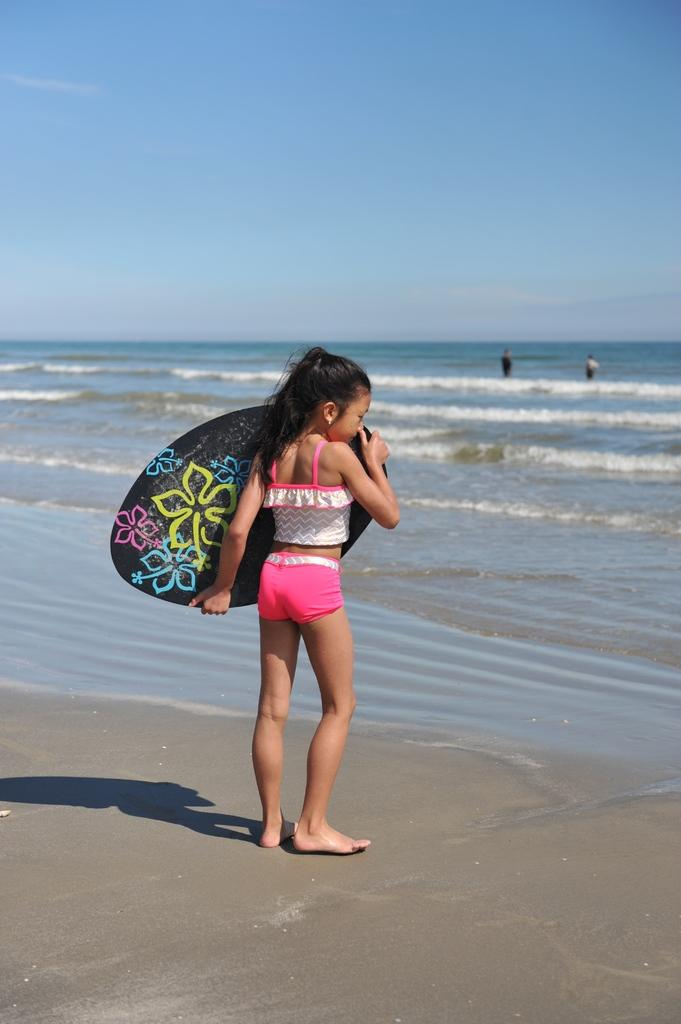What can be seen in the background of the image? There is a sky in the image. What is present in the foreground of the image? There is water in the image. How many people are in the image? There are three people in the image. What is the girl in the image doing? The girl is standing in the image and holding a surfboard. What type of dinner is being served in the image? There is no dinner present in the image; it features a sky, water, and people. Can you describe how the girl is pushing the water in the image? The girl is not pushing the water in the image; she is standing and holding a surfboard. 